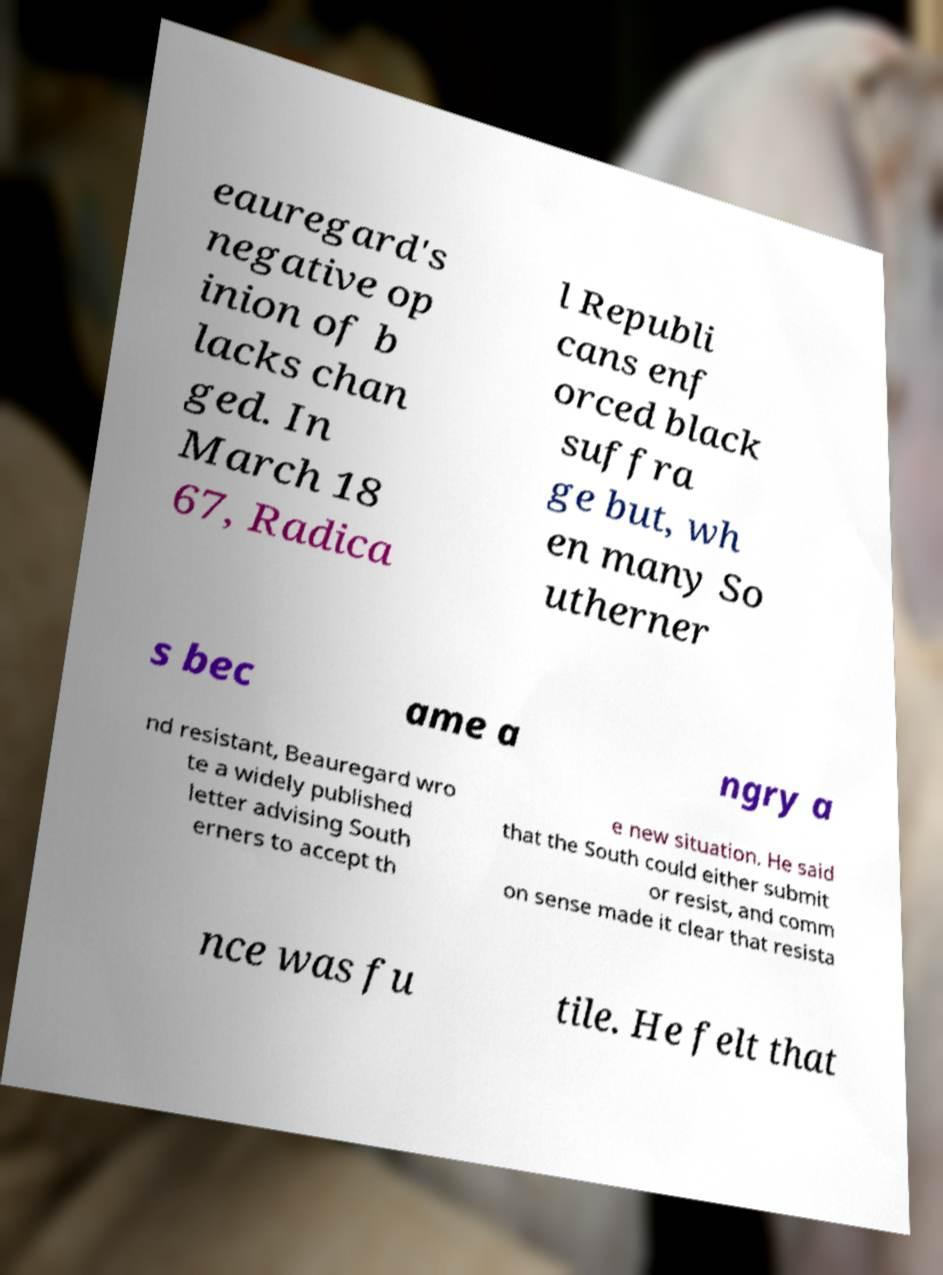Could you assist in decoding the text presented in this image and type it out clearly? eauregard's negative op inion of b lacks chan ged. In March 18 67, Radica l Republi cans enf orced black suffra ge but, wh en many So utherner s bec ame a ngry a nd resistant, Beauregard wro te a widely published letter advising South erners to accept th e new situation. He said that the South could either submit or resist, and comm on sense made it clear that resista nce was fu tile. He felt that 